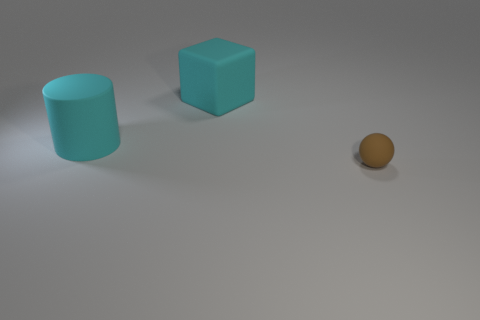What material is the object that is on the right side of the cyan block right of the cyan cylinder made of?
Ensure brevity in your answer.  Rubber. Is there anything else that is the same size as the brown matte ball?
Provide a short and direct response. No. Do the large cyan cylinder and the tiny brown ball right of the matte cube have the same material?
Ensure brevity in your answer.  Yes. There is a object that is in front of the large cyan rubber block and to the left of the small matte ball; what material is it?
Your answer should be very brief. Rubber. What color is the large matte thing on the left side of the object behind the cyan cylinder?
Keep it short and to the point. Cyan. There is a big cyan thing that is right of the cylinder; what is it made of?
Keep it short and to the point. Rubber. Is the number of large cyan metal cylinders less than the number of tiny brown rubber balls?
Keep it short and to the point. Yes. There is a small object; is it the same shape as the big cyan rubber object that is left of the rubber block?
Offer a terse response. No. The rubber object that is both behind the brown ball and in front of the big cube has what shape?
Your answer should be very brief. Cylinder. Is the number of cyan rubber cylinders right of the big cyan cylinder the same as the number of brown rubber objects on the right side of the cyan block?
Provide a short and direct response. No. 